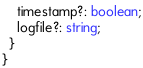Convert code to text. <code><loc_0><loc_0><loc_500><loc_500><_TypeScript_>    timestamp?: boolean;
    logfile?: string;
  }
}
</code> 